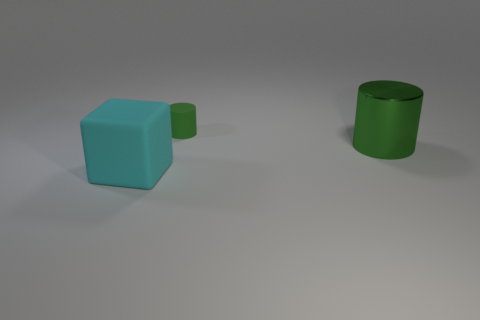What number of other metallic cylinders have the same color as the small cylinder?
Your response must be concise. 1. Is the number of rubber objects that are behind the block the same as the number of big cyan blocks?
Keep it short and to the point. Yes. Do the metallic thing and the rubber cylinder have the same size?
Offer a terse response. No. Is there a green rubber cylinder that is behind the large object that is behind the big cyan matte thing that is on the left side of the small green cylinder?
Your response must be concise. Yes. What material is the big green thing that is the same shape as the small green rubber object?
Ensure brevity in your answer.  Metal. What number of large cyan things are on the left side of the matte thing in front of the large green metal cylinder?
Your answer should be compact. 0. How big is the object that is in front of the cylinder that is on the right side of the matte thing behind the metallic thing?
Give a very brief answer. Large. There is a big thing that is in front of the green thing that is on the right side of the green rubber cylinder; what is its color?
Offer a terse response. Cyan. How many other things are there of the same material as the cyan thing?
Provide a short and direct response. 1. What number of other things are the same color as the tiny rubber object?
Your answer should be compact. 1. 